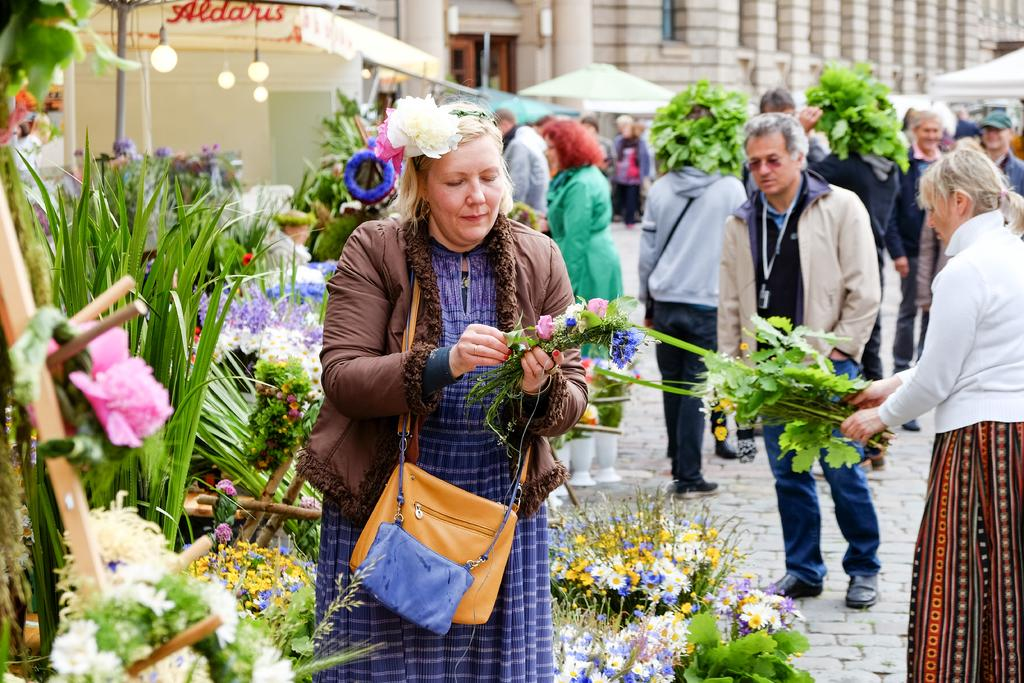What can be seen in the background of the image? There is a building in the distance. What are the people in the image doing? The people are standing and holding leaves with flowers. Can you describe the woman's attire in the image? The woman is wearing a bag and jacket. What is the woman holding in the image? The woman is holding flowers. What type of establishment might the location be? The location appears to be a bouquet shop. How many friends are present in the image? There is no mention of friends in the image; it features people holding leaves with flowers and a woman holding flowers. What type of pet can be seen in the image? There is no pet present in the image. 